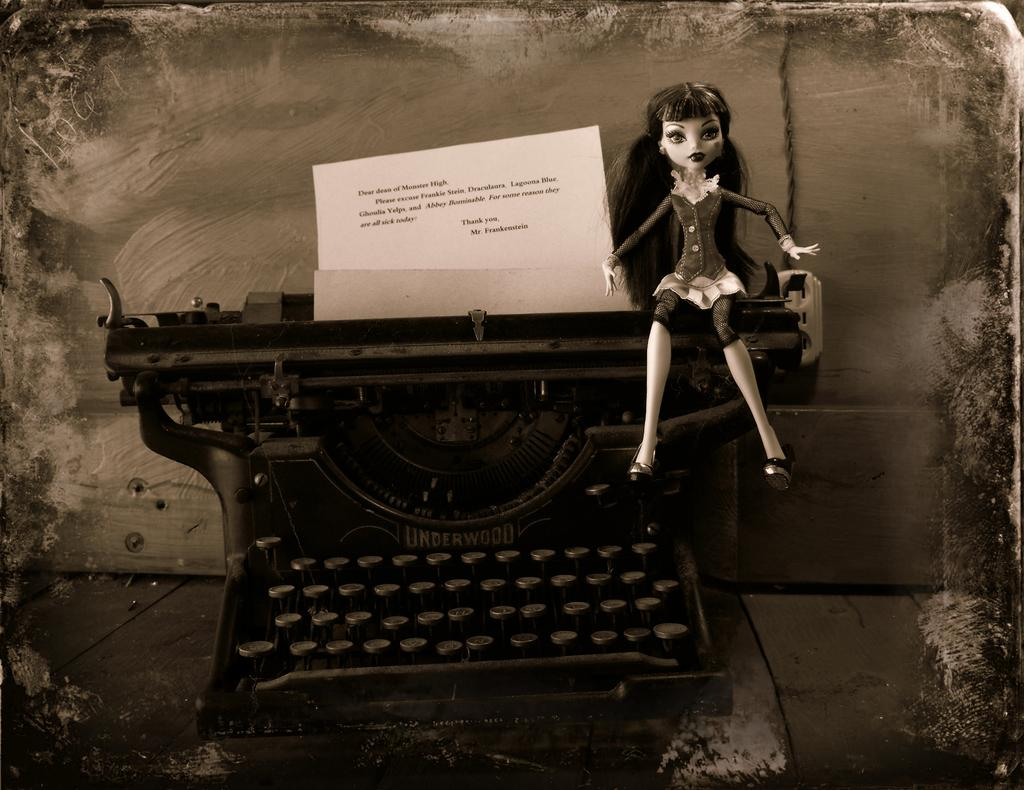What type of object is depicted in the image? There is a toy of a lady in the image. Where is the toy placed? The toy is placed on a machine. What else can be seen in the image besides the toy? There is a paper with text in the image. How many rabbits are hopping around the toy in the image? There are no rabbits present in the image. What type of voice can be heard coming from the toy in the image? The image does not depict any sound or voice; it is a still image. 